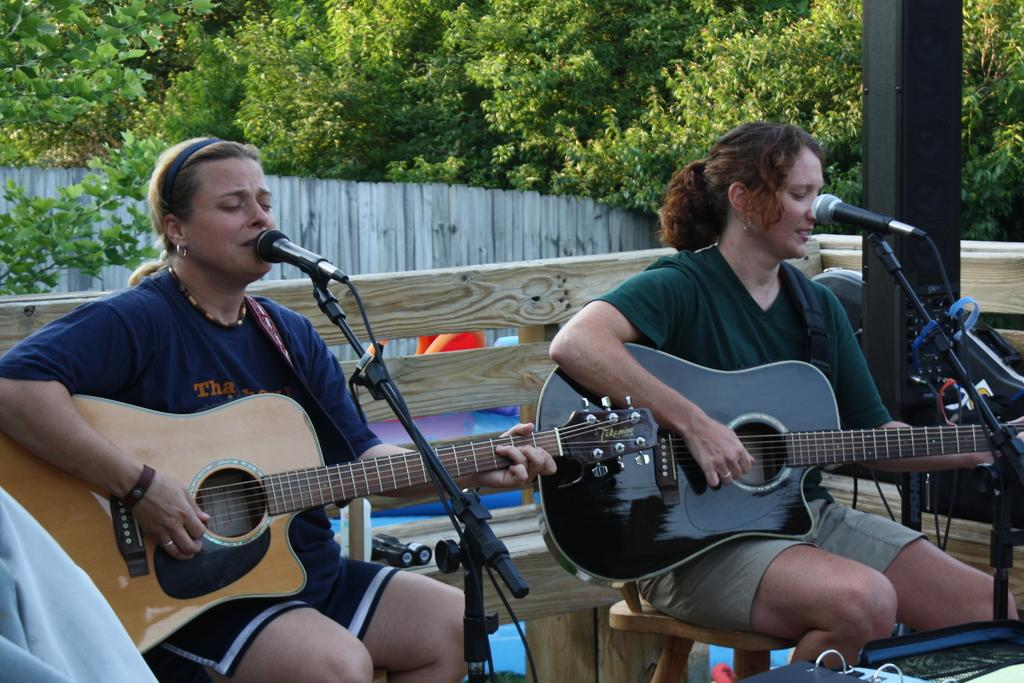How many people are in the image? There are two women in the image. What are the women doing in the image? The women are playing guitars. What object is present for amplifying their voices? There is a microphone in the image. What can be seen in the background of the image? There are trees in the background of the image. Reasoning: Let'g: Let's think step by step in order to produce the conversation. We start by identifying the number of people in the image, which is two women. Then, we describe what they are doing, which is playing guitars. Next, we mention the presence of a microphone, which is related to their activity. Finally, we describe the background of the image, which includes trees. Absurd Question/Answer: What type of tent can be seen in the image? There is no tent present in the image. What language are the women speaking in the image? The image does not provide any information about the language being spoken. What is the main subject of the image? The main subject of the image is a car. What color is the car? The car is red. How many wheels does the car have? The car has four wheels. What type of surface is the car on? The car is on a road. Can you describe the road in the image? The road is paved. Reasoning: Let's think step by step in order to produce the conversation. We start by identifying the main subject of the image, which is the car. Then, we describe specific features of the car, such as its color and the number of wheels. Next, we observe the setting in which the car is located, noting that it is on a road. Finally, we describe the road's characteristics, which is that it is paved. Absurd Question/Answer: Can you see a parrot flying over the ocean in the image? There is no parrot or ocean present in the image. 